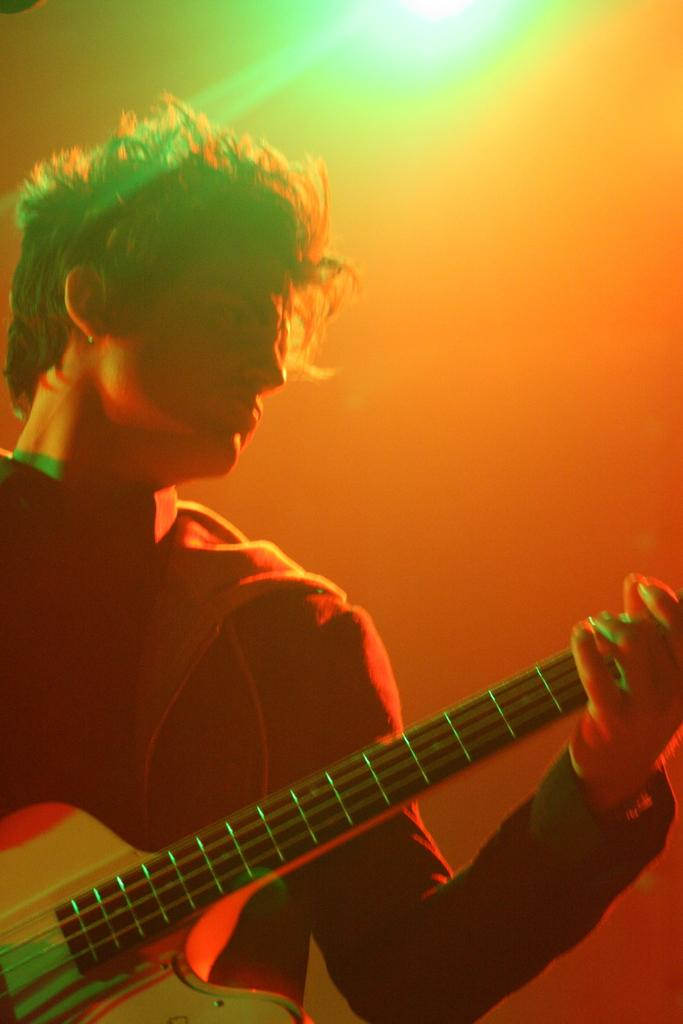What is the main subject of the image? The main subject of the image is a man. What is the man wearing in the image? The man is wearing a red shirt in the image. What object is the man holding in the image? The man is holding a guitar in the image. What type of hydrant can be seen in the background of the image? There is no hydrant present in the image. What suggestions does the man have for improving the hall in the image? The image does not show a hall or any suggestions from the man. 